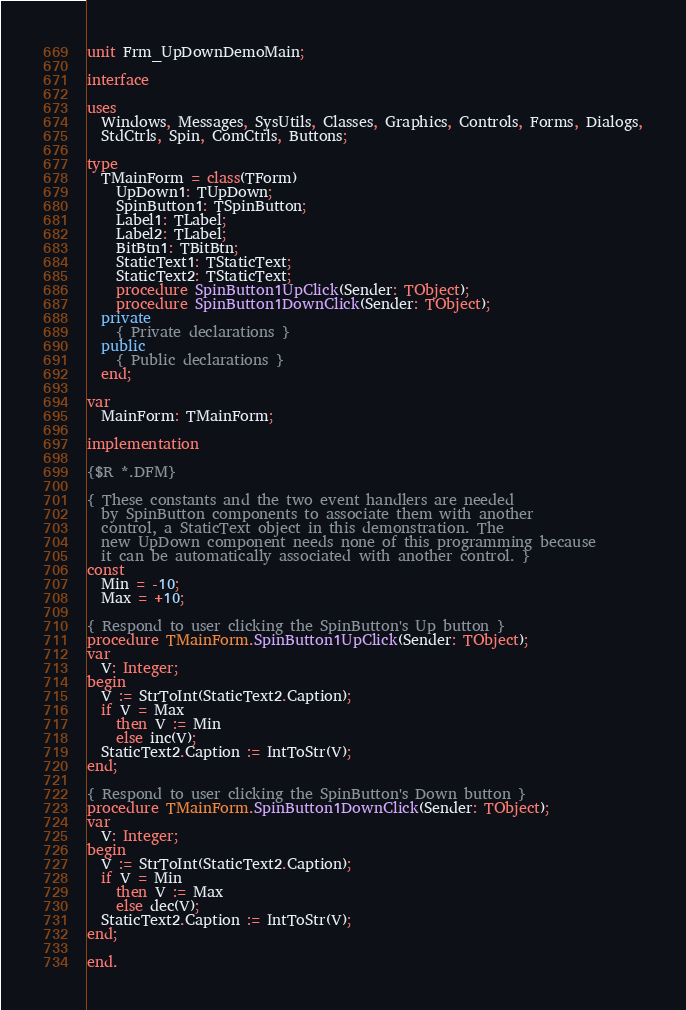Convert code to text. <code><loc_0><loc_0><loc_500><loc_500><_Pascal_>unit Frm_UpDownDemoMain;

interface

uses
  Windows, Messages, SysUtils, Classes, Graphics, Controls, Forms, Dialogs,
  StdCtrls, Spin, ComCtrls, Buttons;

type
  TMainForm = class(TForm)
    UpDown1: TUpDown;
    SpinButton1: TSpinButton;
    Label1: TLabel;
    Label2: TLabel;
    BitBtn1: TBitBtn;
    StaticText1: TStaticText;
    StaticText2: TStaticText;
    procedure SpinButton1UpClick(Sender: TObject);
    procedure SpinButton1DownClick(Sender: TObject);
  private
    { Private declarations }
  public
    { Public declarations }
  end;

var
  MainForm: TMainForm;

implementation

{$R *.DFM}

{ These constants and the two event handlers are needed
  by SpinButton components to associate them with another
  control, a StaticText object in this demonstration. The
  new UpDown component needs none of this programming because
  it can be automatically associated with another control. }
const
  Min = -10;
  Max = +10;

{ Respond to user clicking the SpinButton's Up button }
procedure TMainForm.SpinButton1UpClick(Sender: TObject);
var
  V: Integer;
begin
  V := StrToInt(StaticText2.Caption);
  if V = Max
    then V := Min
    else inc(V);
  StaticText2.Caption := IntToStr(V);
end;

{ Respond to user clicking the SpinButton's Down button }
procedure TMainForm.SpinButton1DownClick(Sender: TObject);
var
  V: Integer;
begin
  V := StrToInt(StaticText2.Caption);
  if V = Min
    then V := Max
    else dec(V);
  StaticText2.Caption := IntToStr(V);
end;

end.
</code> 